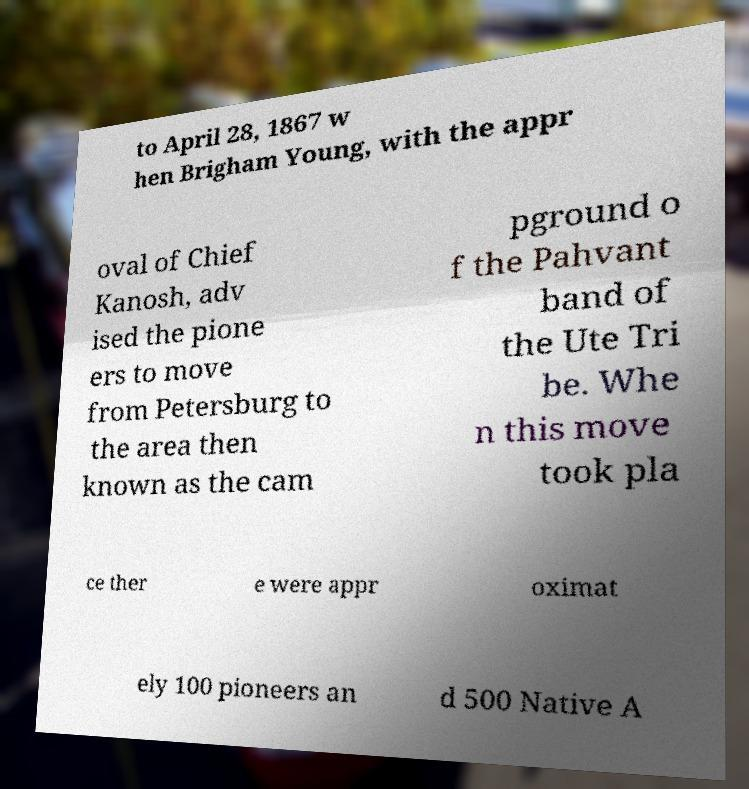Can you accurately transcribe the text from the provided image for me? to April 28, 1867 w hen Brigham Young, with the appr oval of Chief Kanosh, adv ised the pione ers to move from Petersburg to the area then known as the cam pground o f the Pahvant band of the Ute Tri be. Whe n this move took pla ce ther e were appr oximat ely 100 pioneers an d 500 Native A 